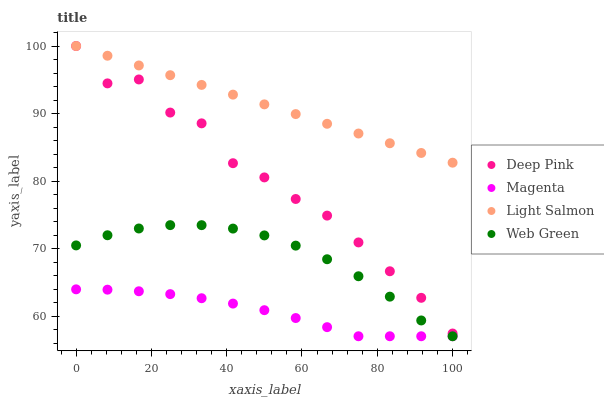Does Magenta have the minimum area under the curve?
Answer yes or no. Yes. Does Light Salmon have the maximum area under the curve?
Answer yes or no. Yes. Does Deep Pink have the minimum area under the curve?
Answer yes or no. No. Does Deep Pink have the maximum area under the curve?
Answer yes or no. No. Is Light Salmon the smoothest?
Answer yes or no. Yes. Is Deep Pink the roughest?
Answer yes or no. Yes. Is Deep Pink the smoothest?
Answer yes or no. No. Is Light Salmon the roughest?
Answer yes or no. No. Does Magenta have the lowest value?
Answer yes or no. Yes. Does Deep Pink have the lowest value?
Answer yes or no. No. Does Light Salmon have the highest value?
Answer yes or no. Yes. Does Web Green have the highest value?
Answer yes or no. No. Is Web Green less than Deep Pink?
Answer yes or no. Yes. Is Deep Pink greater than Web Green?
Answer yes or no. Yes. Does Web Green intersect Magenta?
Answer yes or no. Yes. Is Web Green less than Magenta?
Answer yes or no. No. Is Web Green greater than Magenta?
Answer yes or no. No. Does Web Green intersect Deep Pink?
Answer yes or no. No. 